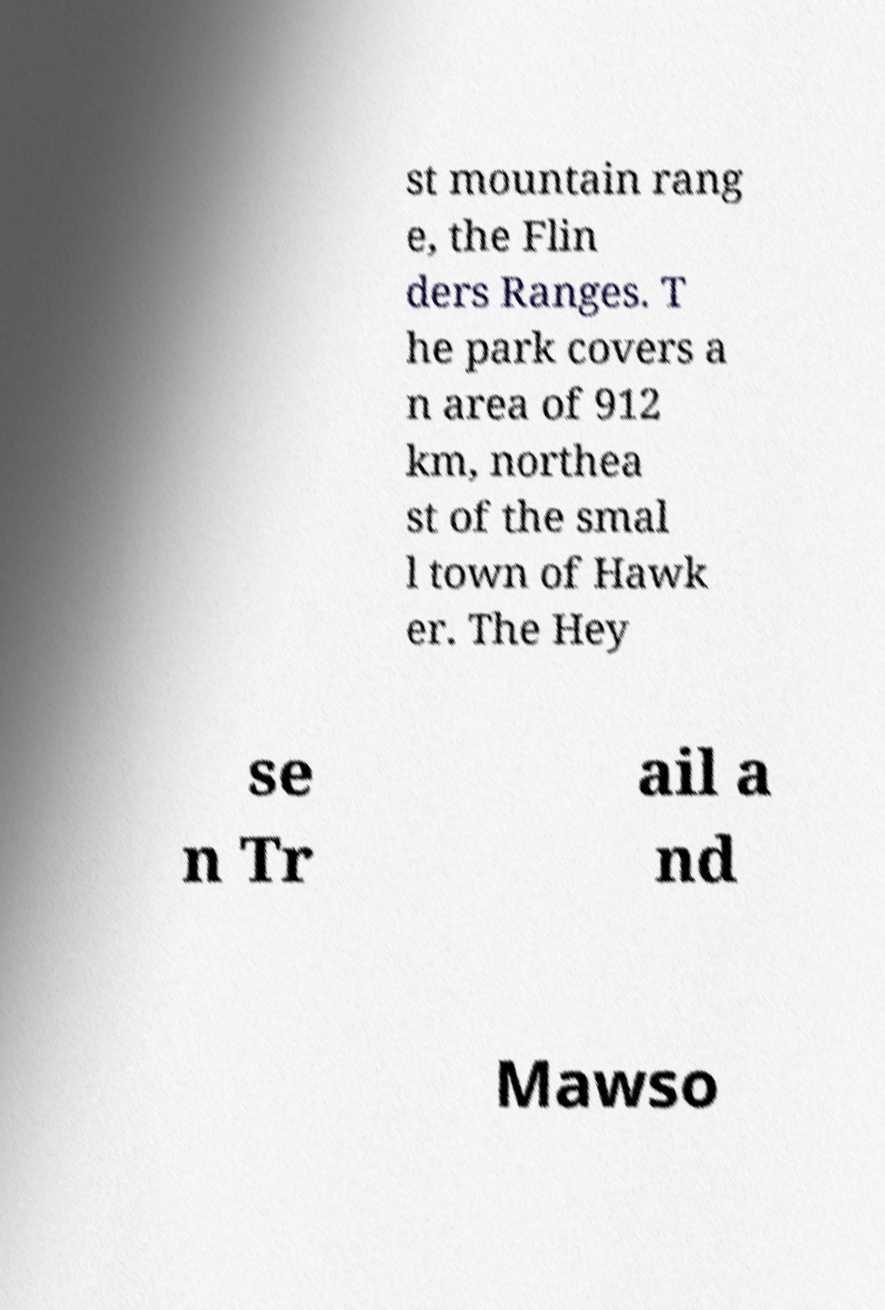Could you extract and type out the text from this image? st mountain rang e, the Flin ders Ranges. T he park covers a n area of 912 km, northea st of the smal l town of Hawk er. The Hey se n Tr ail a nd Mawso 